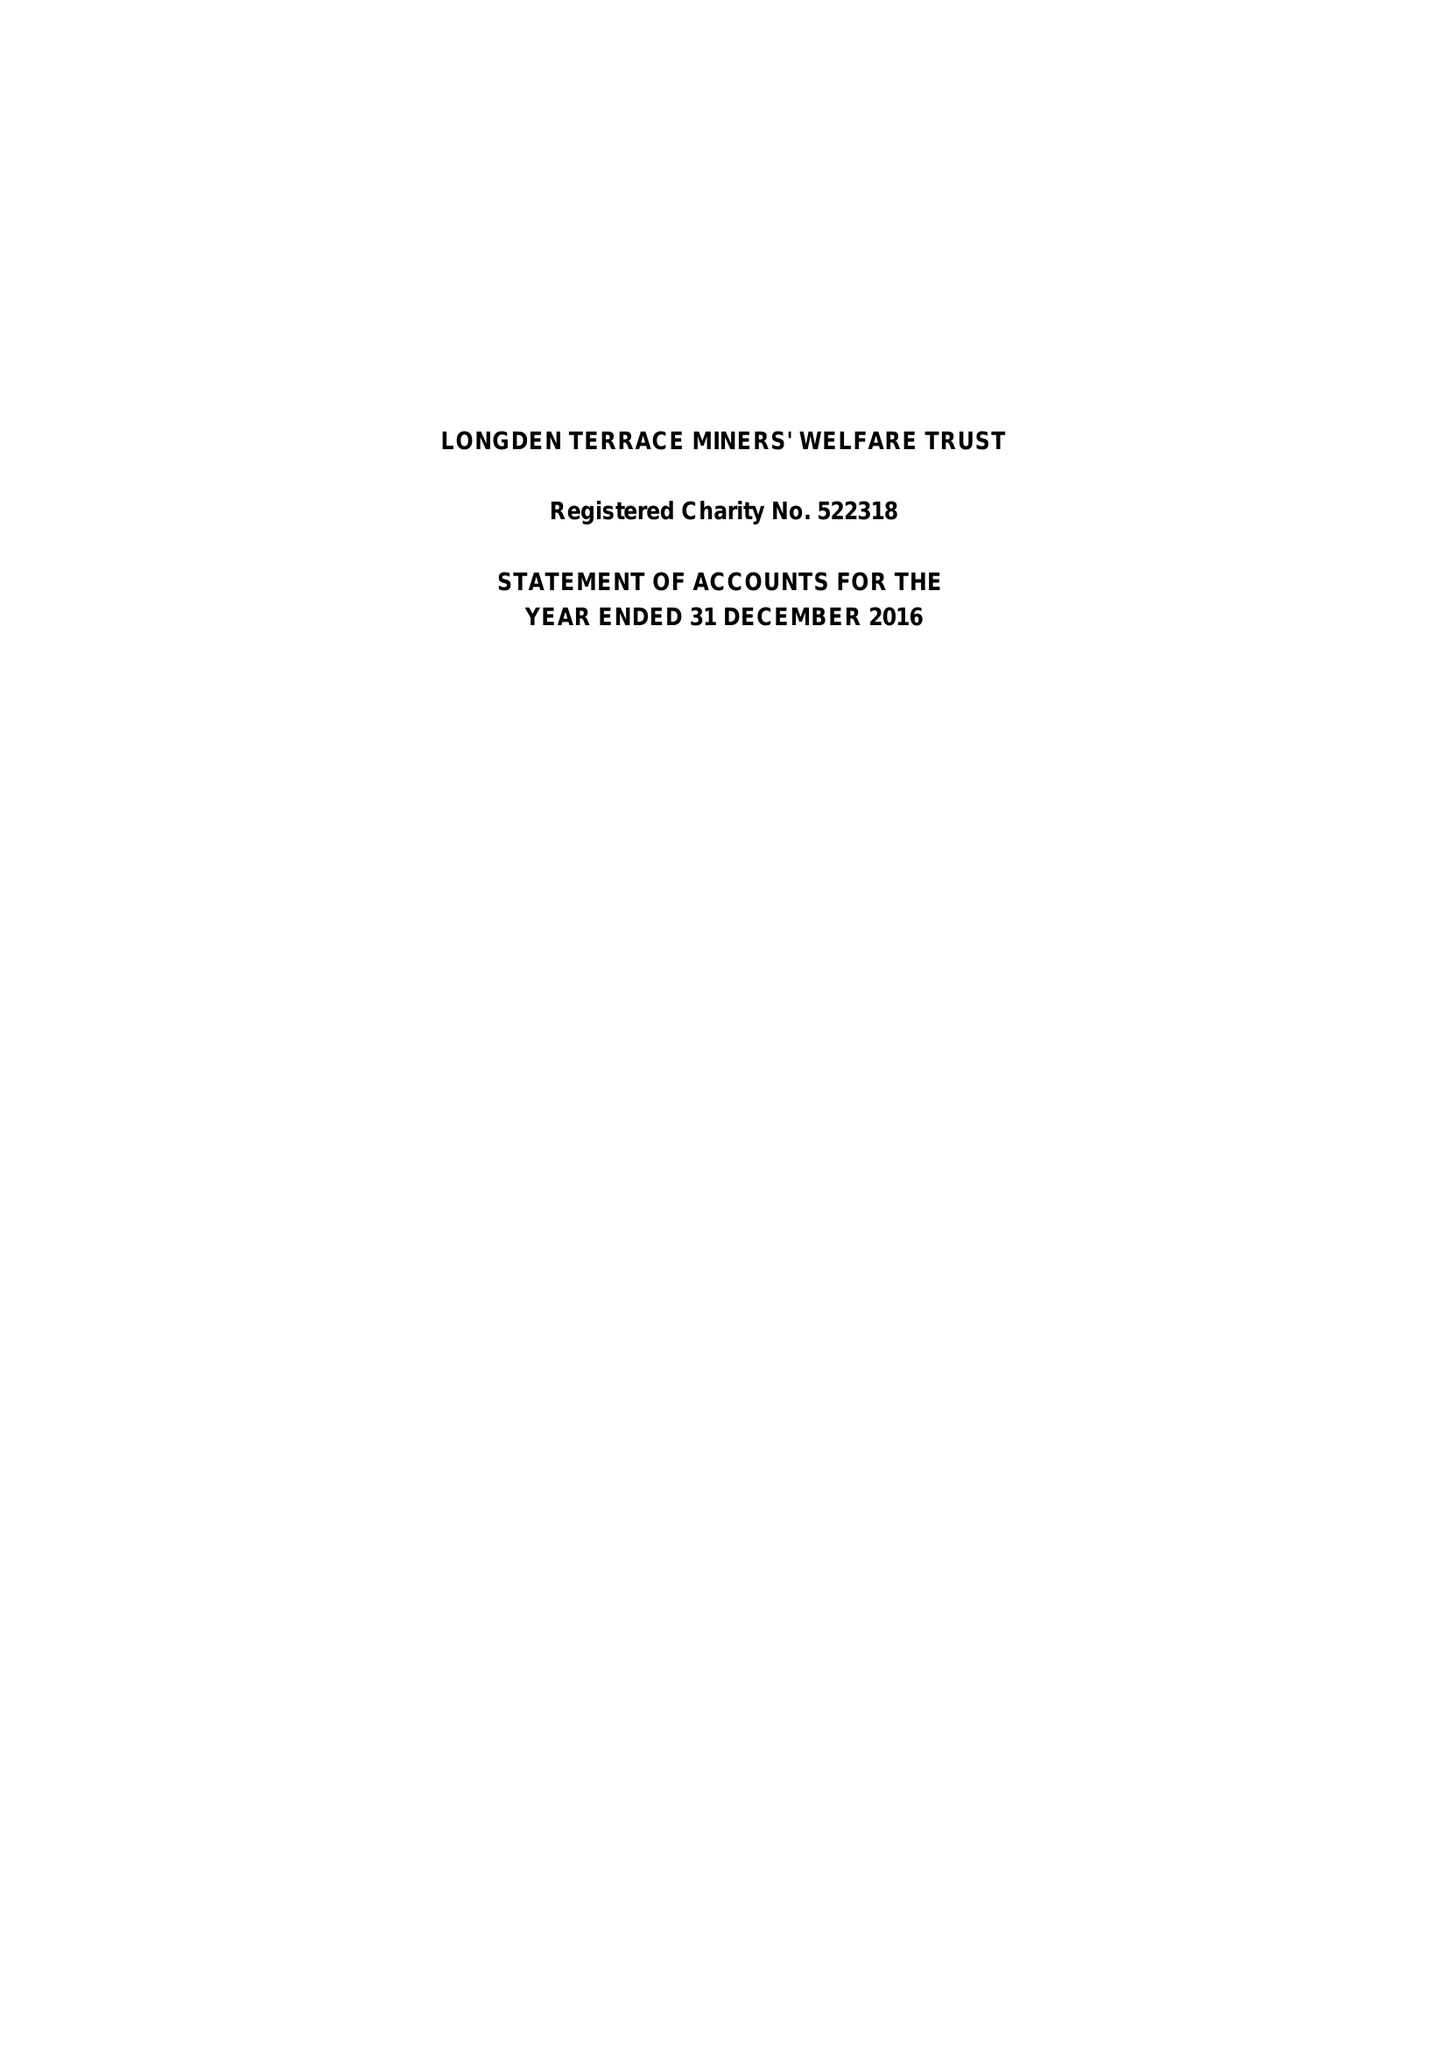What is the value for the report_date?
Answer the question using a single word or phrase. 2016-12-31 